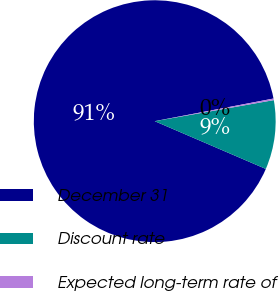Convert chart. <chart><loc_0><loc_0><loc_500><loc_500><pie_chart><fcel>December 31<fcel>Discount rate<fcel>Expected long-term rate of<nl><fcel>90.54%<fcel>9.25%<fcel>0.21%<nl></chart> 